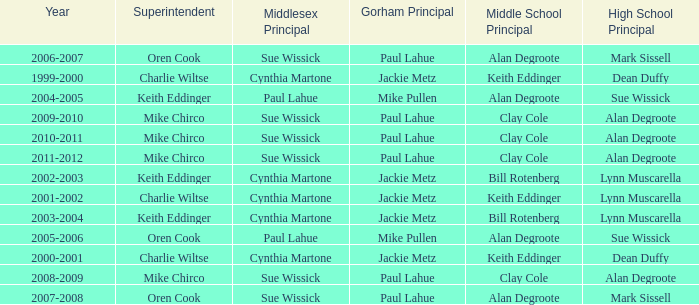Who were the superintendent(s) when the middle school principal was alan degroote, the gorham principal was paul lahue, and the year was 2006-2007? Oren Cook. Could you parse the entire table? {'header': ['Year', 'Superintendent', 'Middlesex Principal', 'Gorham Principal', 'Middle School Principal', 'High School Principal'], 'rows': [['2006-2007', 'Oren Cook', 'Sue Wissick', 'Paul Lahue', 'Alan Degroote', 'Mark Sissell'], ['1999-2000', 'Charlie Wiltse', 'Cynthia Martone', 'Jackie Metz', 'Keith Eddinger', 'Dean Duffy'], ['2004-2005', 'Keith Eddinger', 'Paul Lahue', 'Mike Pullen', 'Alan Degroote', 'Sue Wissick'], ['2009-2010', 'Mike Chirco', 'Sue Wissick', 'Paul Lahue', 'Clay Cole', 'Alan Degroote'], ['2010-2011', 'Mike Chirco', 'Sue Wissick', 'Paul Lahue', 'Clay Cole', 'Alan Degroote'], ['2011-2012', 'Mike Chirco', 'Sue Wissick', 'Paul Lahue', 'Clay Cole', 'Alan Degroote'], ['2002-2003', 'Keith Eddinger', 'Cynthia Martone', 'Jackie Metz', 'Bill Rotenberg', 'Lynn Muscarella'], ['2001-2002', 'Charlie Wiltse', 'Cynthia Martone', 'Jackie Metz', 'Keith Eddinger', 'Lynn Muscarella'], ['2003-2004', 'Keith Eddinger', 'Cynthia Martone', 'Jackie Metz', 'Bill Rotenberg', 'Lynn Muscarella'], ['2005-2006', 'Oren Cook', 'Paul Lahue', 'Mike Pullen', 'Alan Degroote', 'Sue Wissick'], ['2000-2001', 'Charlie Wiltse', 'Cynthia Martone', 'Jackie Metz', 'Keith Eddinger', 'Dean Duffy'], ['2008-2009', 'Mike Chirco', 'Sue Wissick', 'Paul Lahue', 'Clay Cole', 'Alan Degroote'], ['2007-2008', 'Oren Cook', 'Sue Wissick', 'Paul Lahue', 'Alan Degroote', 'Mark Sissell']]} 